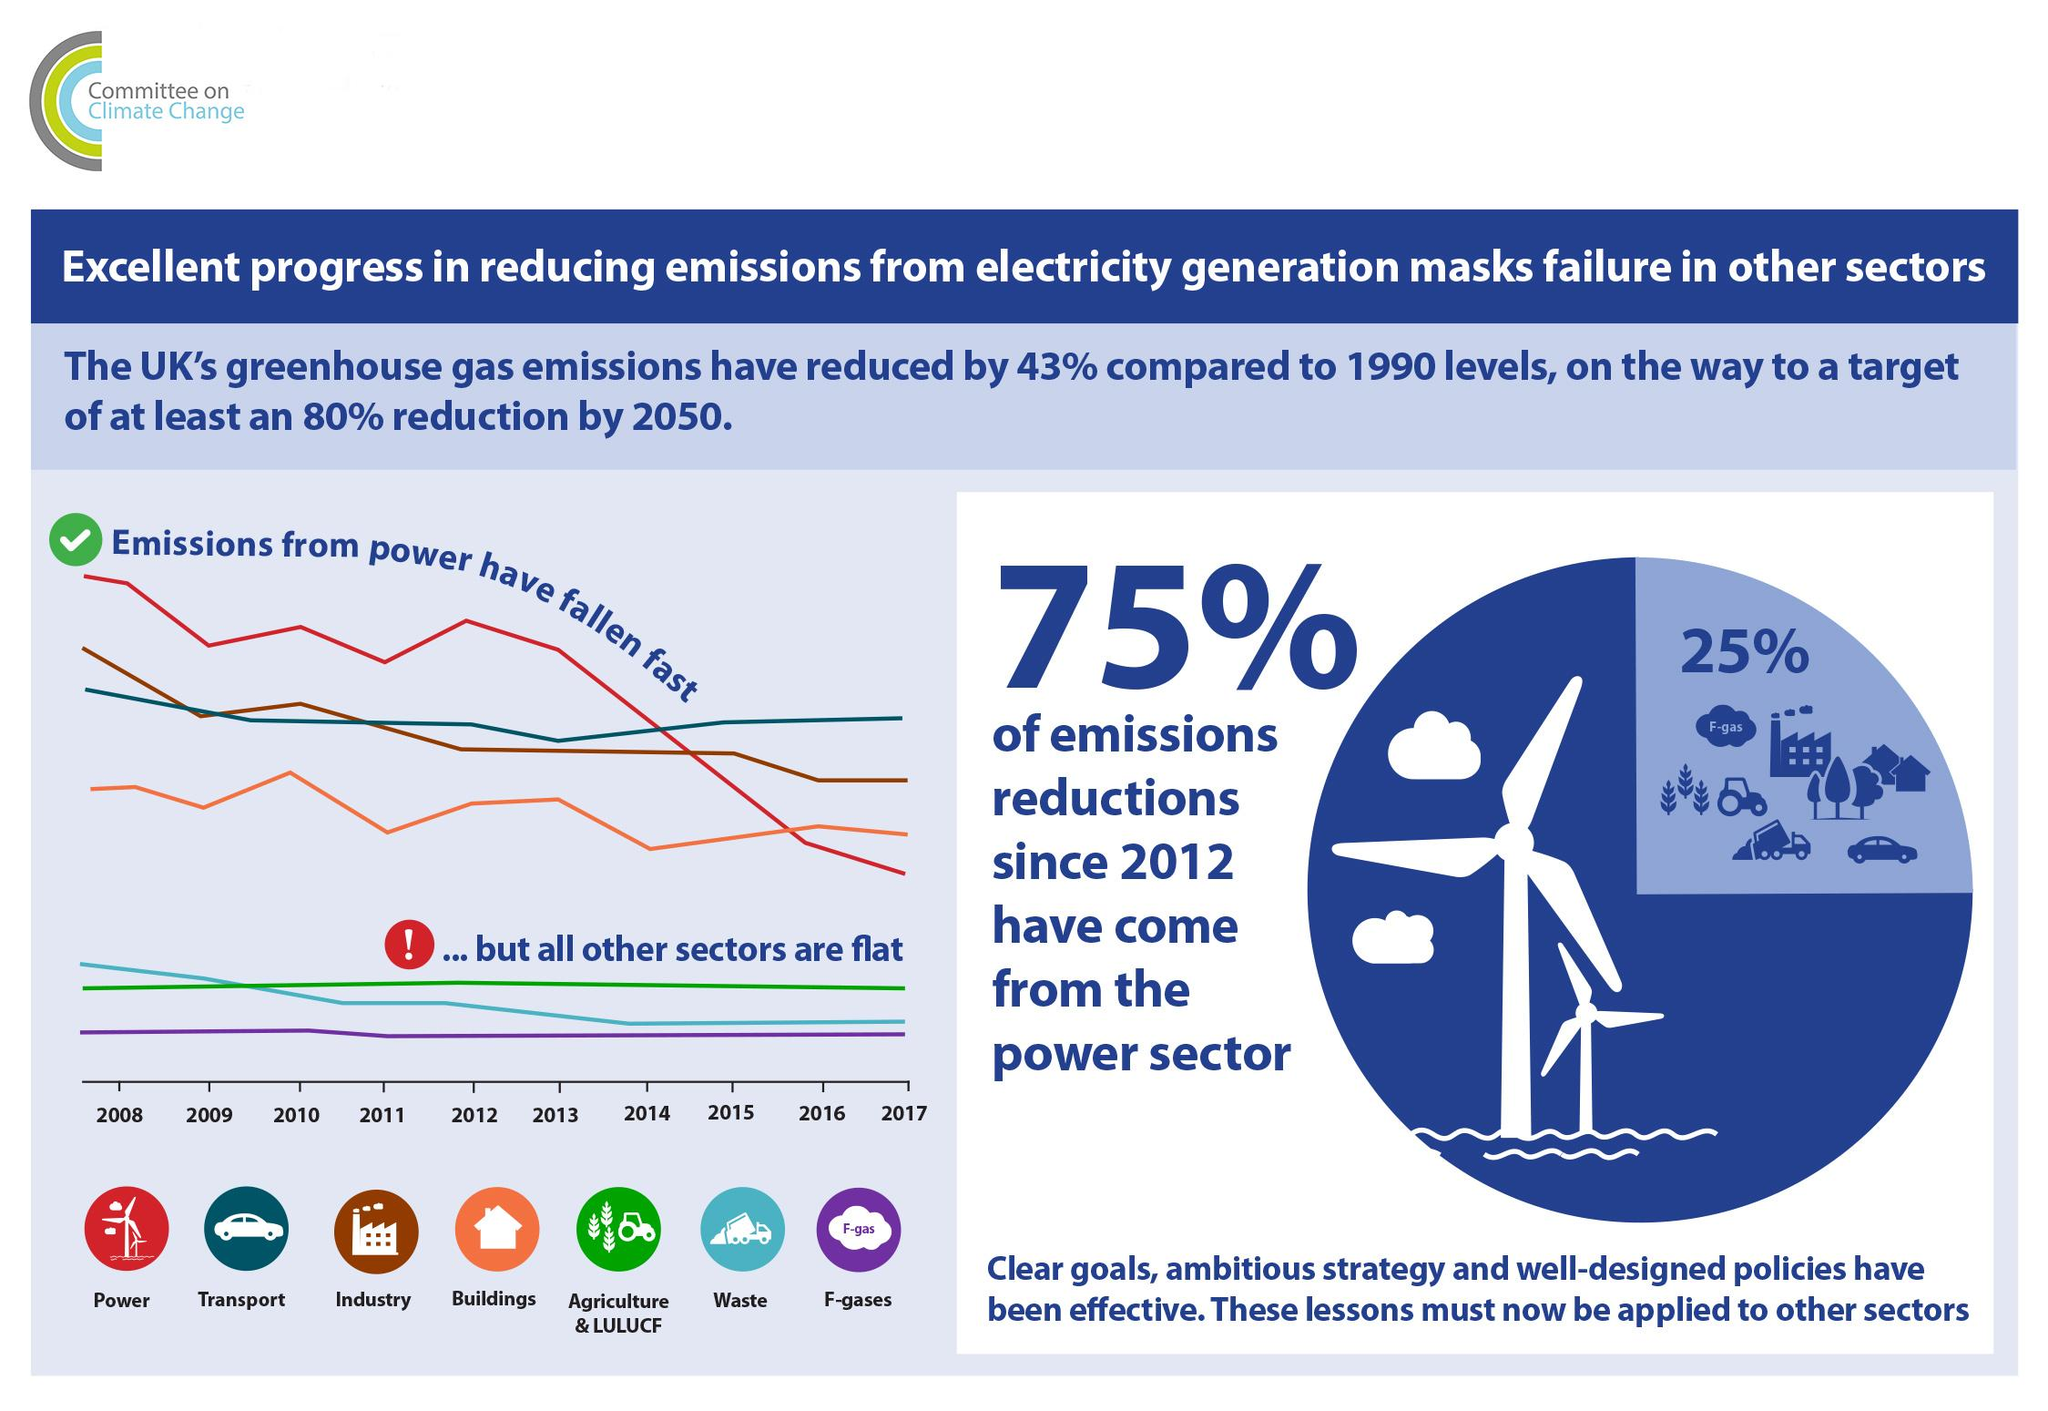Specify some key components in this picture. The power sector has made the greatest contribution to reducing emissions since 2012. 